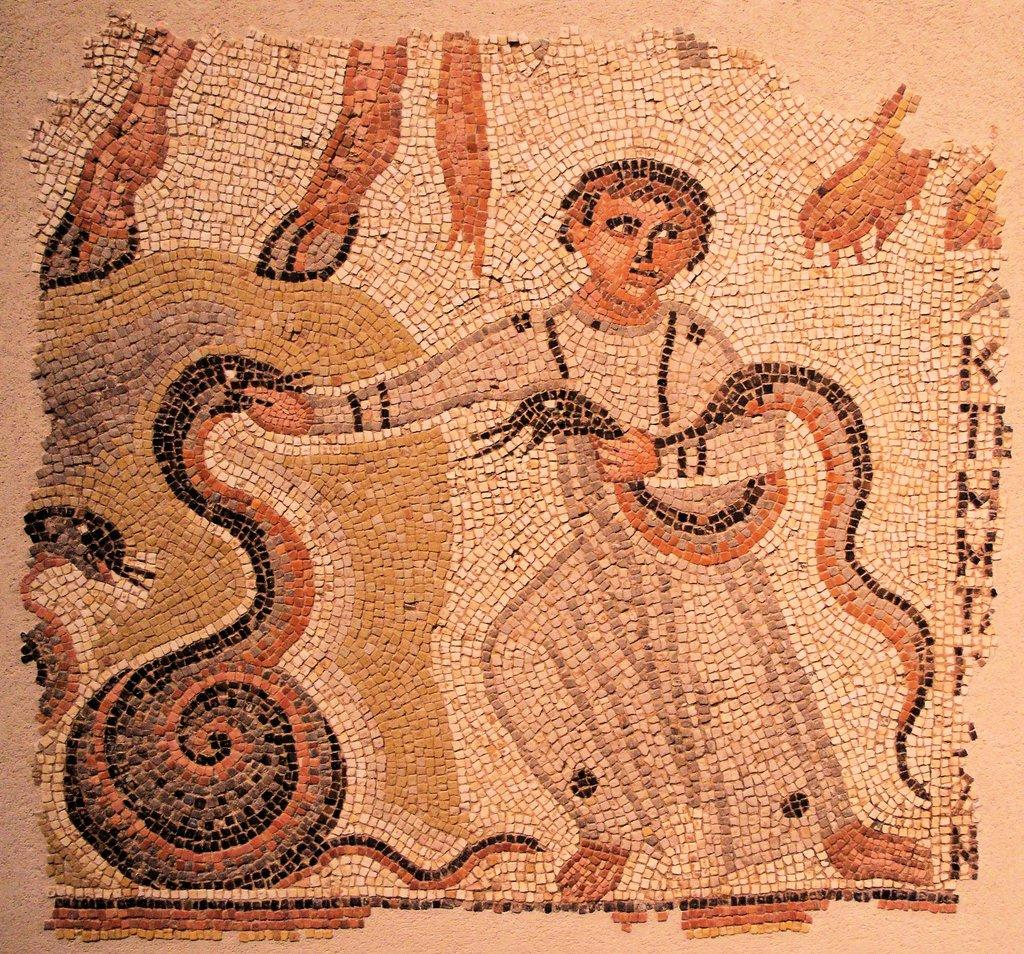What is the main structure visible in the image? There is a platform in the image. What type of art is featured on the platform? There is a mosaic art on the platform. What animals are depicted in the mosaic art? The mosaic art features snakes. Are there any human figures in the mosaic art? Yes, the mosaic art includes a person. What type of fuel is used to power the airplane in the image? There is no airplane present in the image, so it is not possible to determine the type of fuel used. 